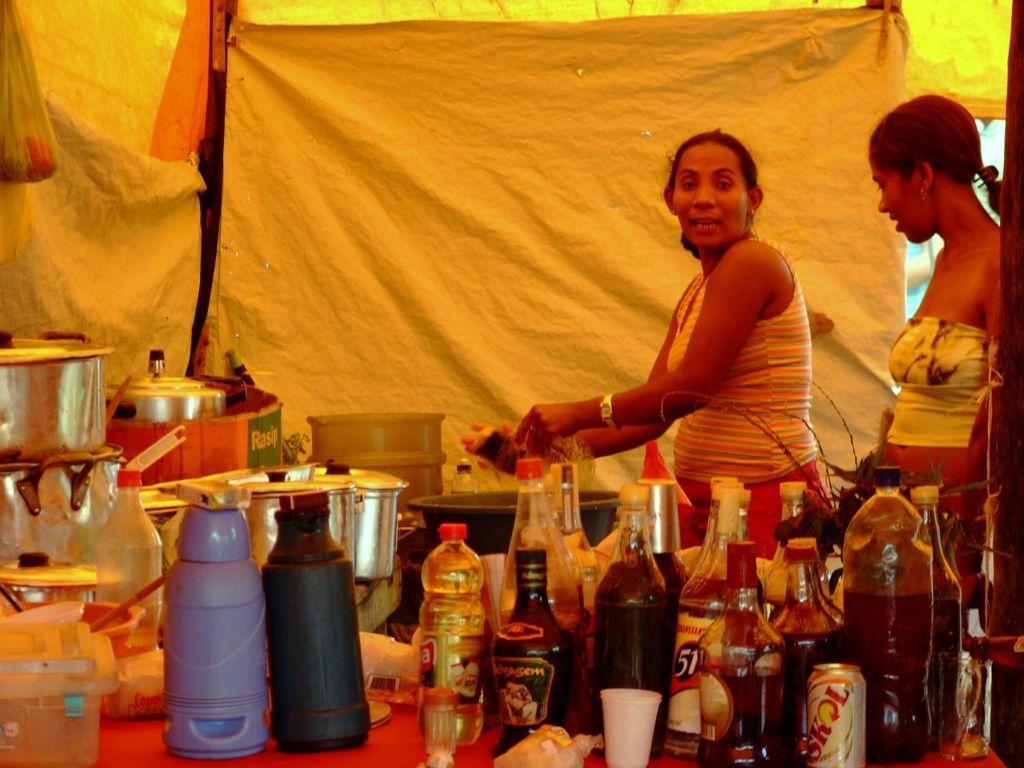In one or two sentences, can you explain what this image depicts? In the picture we can find two women are standing and cooking near the desk there are some bottled, water, vinegar, tins and a background we can find curtains, covers and cover bags. 